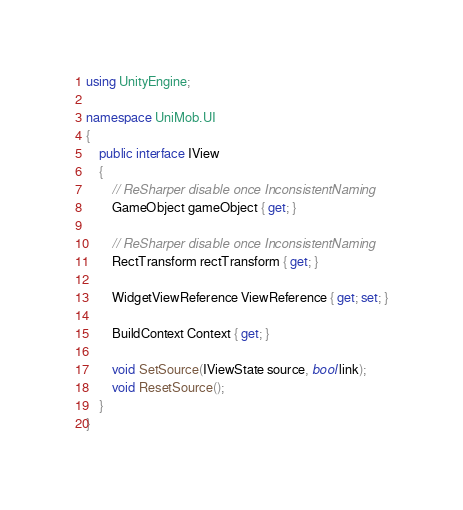Convert code to text. <code><loc_0><loc_0><loc_500><loc_500><_C#_>using UnityEngine;

namespace UniMob.UI
{
    public interface IView
    {
        // ReSharper disable once InconsistentNaming
        GameObject gameObject { get; }

        // ReSharper disable once InconsistentNaming
        RectTransform rectTransform { get; }

        WidgetViewReference ViewReference { get; set; }

        BuildContext Context { get; }

        void SetSource(IViewState source, bool link);
        void ResetSource();
    }
}</code> 